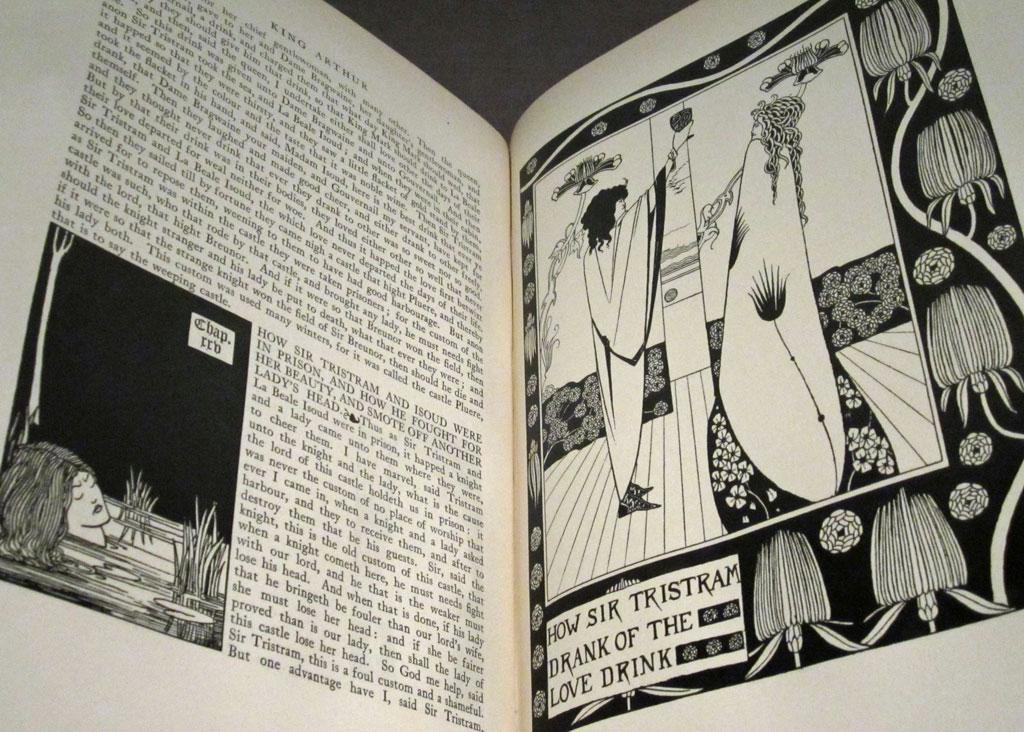Provide a one-sentence caption for the provided image. the word Tristram is on the book with many pictures. 